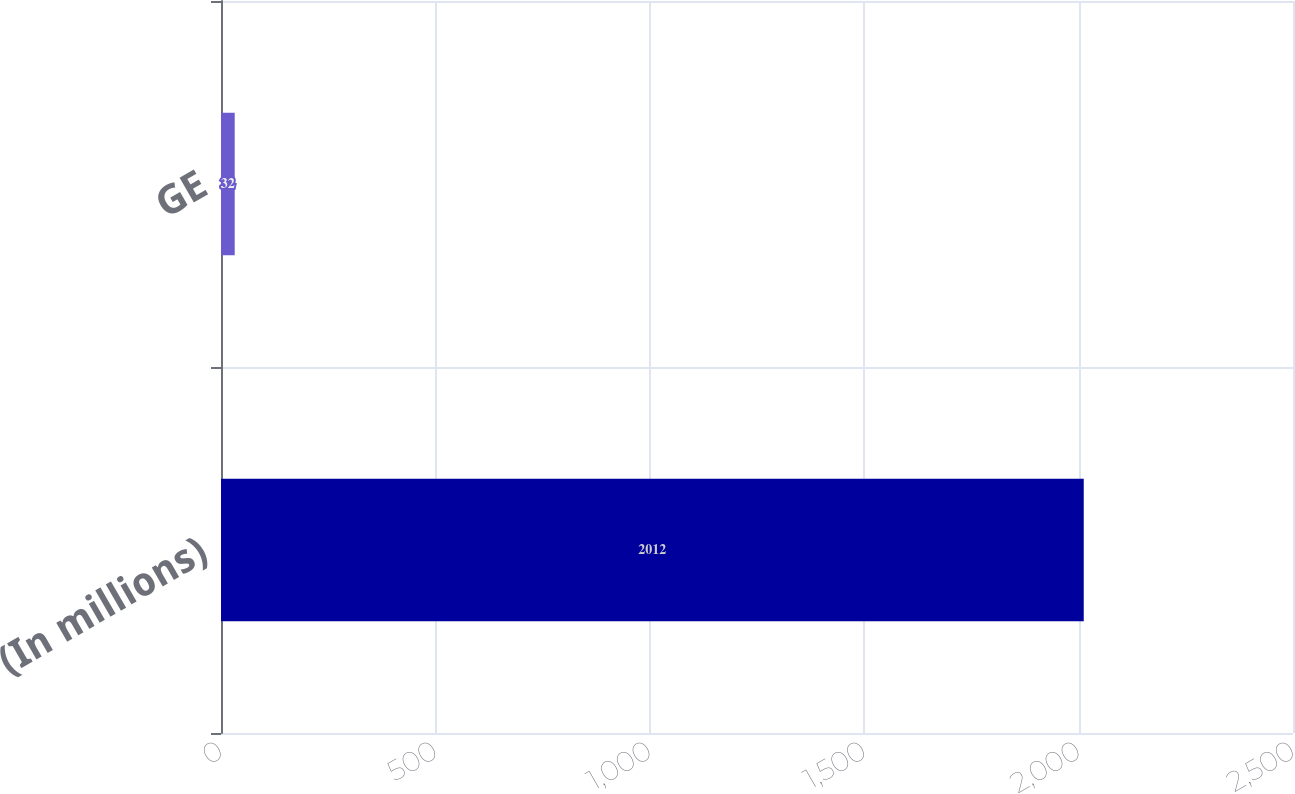<chart> <loc_0><loc_0><loc_500><loc_500><bar_chart><fcel>(In millions)<fcel>GE<nl><fcel>2012<fcel>32<nl></chart> 